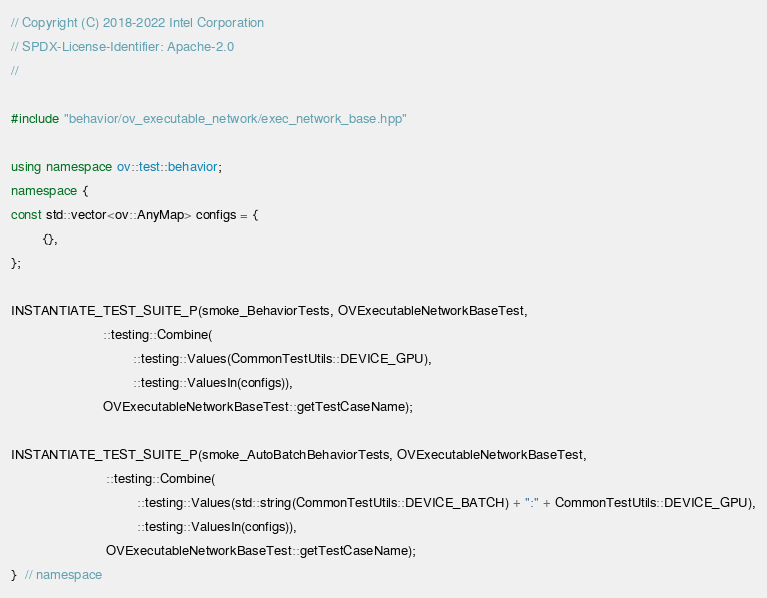<code> <loc_0><loc_0><loc_500><loc_500><_C++_>// Copyright (C) 2018-2022 Intel Corporation
// SPDX-License-Identifier: Apache-2.0
//

#include "behavior/ov_executable_network/exec_network_base.hpp"

using namespace ov::test::behavior;
namespace {
const std::vector<ov::AnyMap> configs = {
        {},
};

INSTANTIATE_TEST_SUITE_P(smoke_BehaviorTests, OVExecutableNetworkBaseTest,
                        ::testing::Combine(
                                ::testing::Values(CommonTestUtils::DEVICE_GPU),
                                ::testing::ValuesIn(configs)),
                        OVExecutableNetworkBaseTest::getTestCaseName);

INSTANTIATE_TEST_SUITE_P(smoke_AutoBatchBehaviorTests, OVExecutableNetworkBaseTest,
                         ::testing::Combine(
                                 ::testing::Values(std::string(CommonTestUtils::DEVICE_BATCH) + ":" + CommonTestUtils::DEVICE_GPU),
                                 ::testing::ValuesIn(configs)),
                         OVExecutableNetworkBaseTest::getTestCaseName);
}  // namespace</code> 